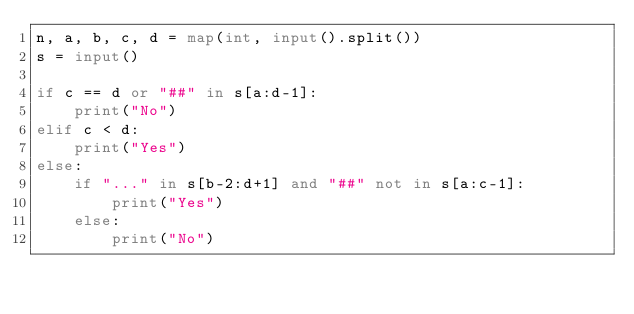<code> <loc_0><loc_0><loc_500><loc_500><_Python_>n, a, b, c, d = map(int, input().split())
s = input()

if c == d or "##" in s[a:d-1]:
    print("No")
elif c < d:
    print("Yes")
else:
    if "..." in s[b-2:d+1] and "##" not in s[a:c-1]:
        print("Yes")
    else:
        print("No")
</code> 